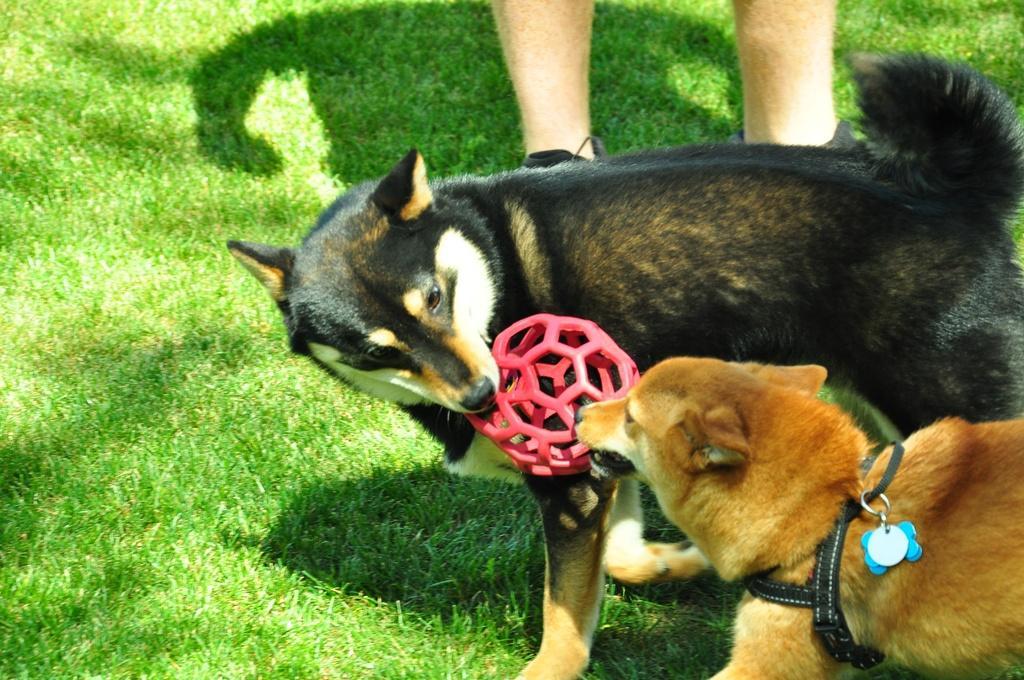Describe this image in one or two sentences. To the right corner of the image there is a brown dog with black belt and blue key chain on it. Beside that dog there is another black dog standing. In their mouths there is a red color object. And to the top of the image there are person legs. And the dogs are standing on the grass. 